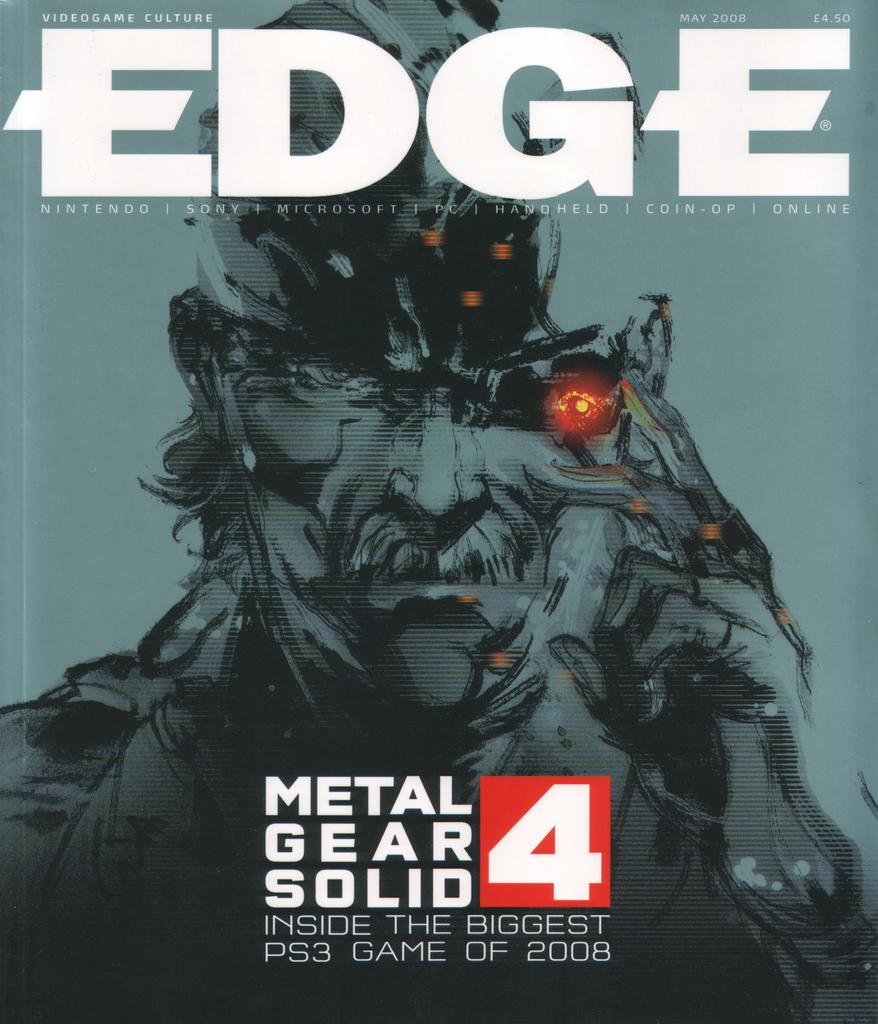What is featured in the picture? There is a poster in the picture. Can you describe the layout of the poster? The poster has text at the top and bottom, with a graphical image of a human in between. What type of polish is being applied to the human in the image? There is no polish or application process depicted in the image; it features a poster with text and a graphical image of a human. 